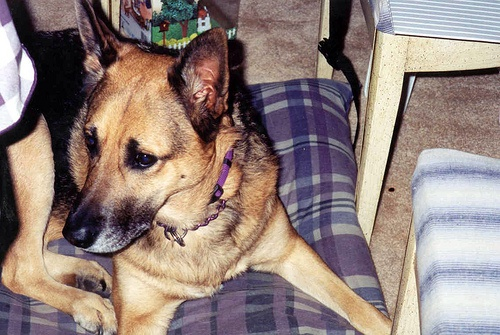Describe the objects in this image and their specific colors. I can see dog in gray, tan, and black tones, chair in gray, lightgray, and darkgray tones, and chair in gray, beige, and darkgray tones in this image. 